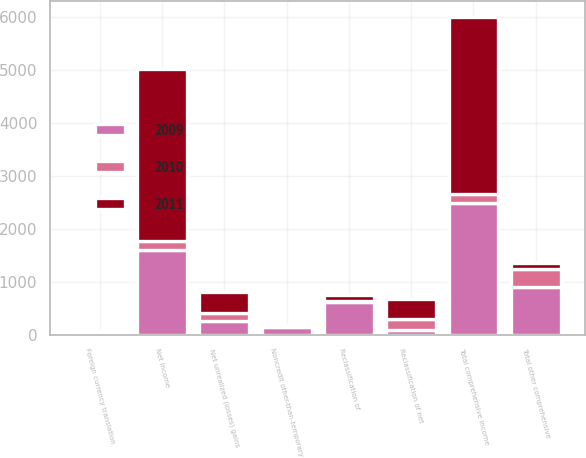<chart> <loc_0><loc_0><loc_500><loc_500><stacked_bar_chart><ecel><fcel>Net income<fcel>Foreign currency translation<fcel>Noncredit other-than-temporary<fcel>Net unrealized (losses) gains<fcel>Reclassification of net<fcel>Reclassification of<fcel>Total other comprehensive<fcel>Total comprehensive income<nl><fcel>2010<fcel>172<fcel>9<fcel>19<fcel>145<fcel>199<fcel>25<fcel>347<fcel>172<nl><fcel>2011<fcel>3247<fcel>40<fcel>21<fcel>392<fcel>380<fcel>116<fcel>109<fcel>3356<nl><fcel>2009<fcel>1592<fcel>25<fcel>135<fcel>261<fcel>93<fcel>613<fcel>891<fcel>2483<nl></chart> 